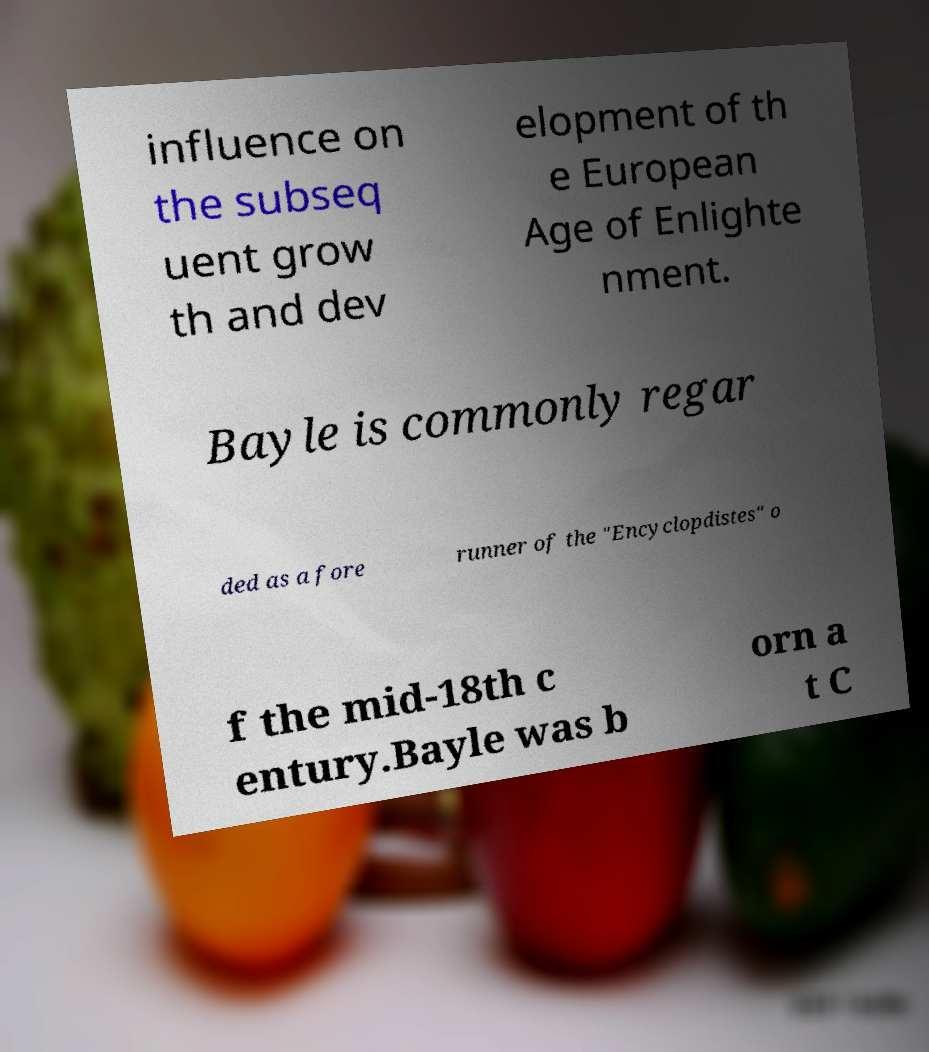Could you extract and type out the text from this image? influence on the subseq uent grow th and dev elopment of th e European Age of Enlighte nment. Bayle is commonly regar ded as a fore runner of the "Encyclopdistes" o f the mid-18th c entury.Bayle was b orn a t C 